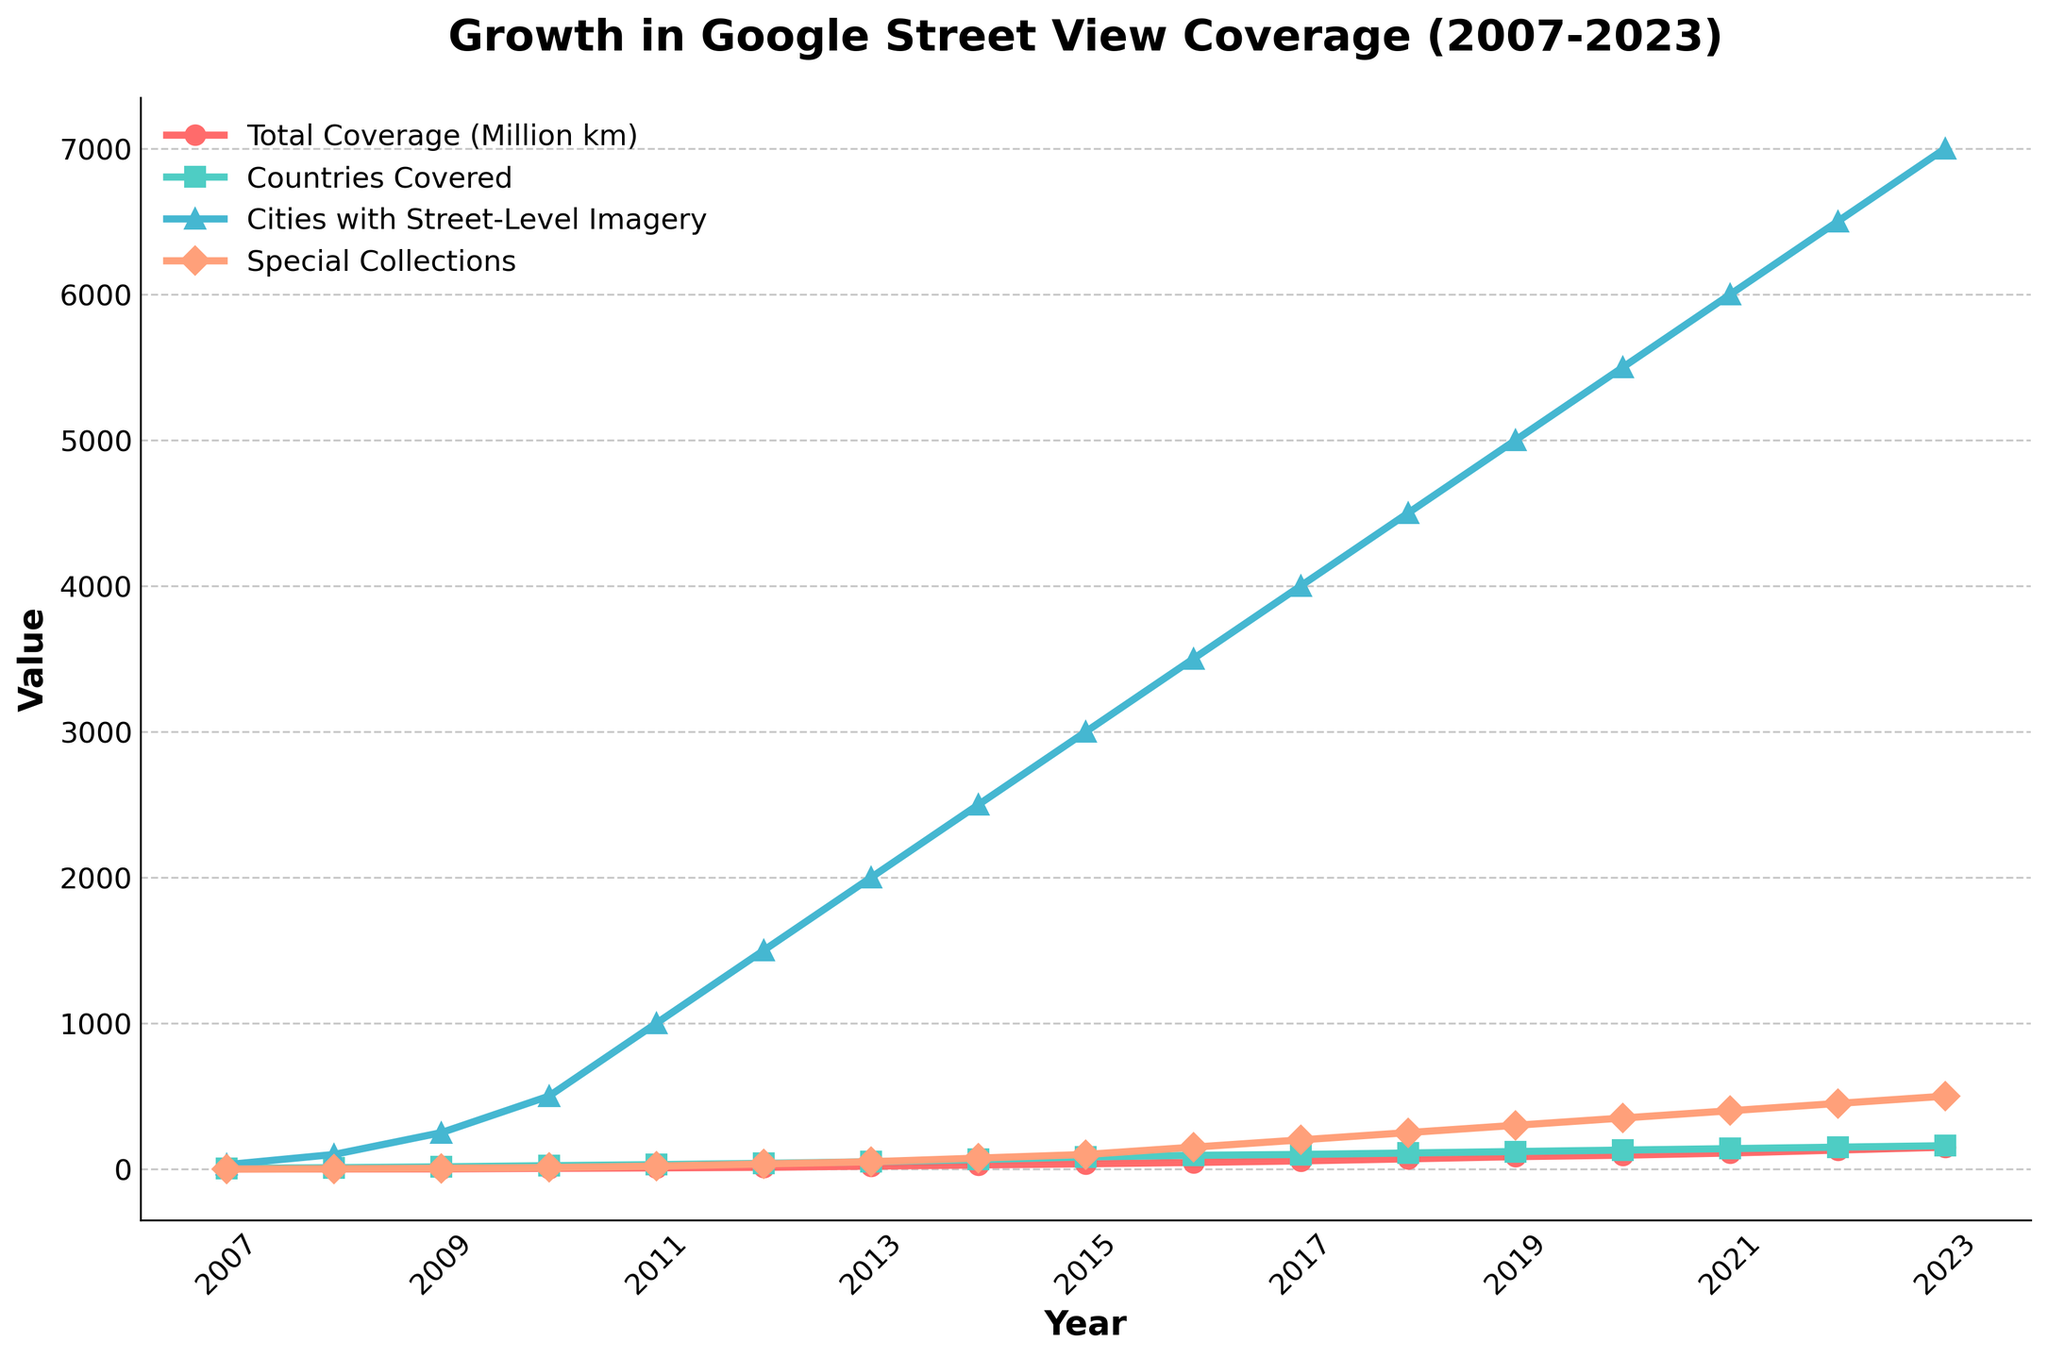What year did Google Street View first reach 10 million km of total coverage? Refer to the "Total Coverage (Million km)" line in the figure. It shows that the total coverage surpassed 10 million km in the year 2010.
Answer: 2010 Between which consecutive years did Google Street View experience the highest increase in the number of cities with street-level imagery? Compare the increases in the "Cities with Street-Level Imagery" line for each consecutive year. The largest increase occurs between 2010 and 2011, where the number rose from 500 to 1000.
Answer: 2010-2011 How many countries did Google Street View cover by 2015? Refer to the "Countries Covered" line in the figure for the year 2015. It shows that 83 countries were covered by Google Street View in that year.
Answer: 83 Which year saw the largest single-year increase in total km coverage, and how much was the increase? Compare yearly increments in the "Total Coverage (Million km)" line. The largest increase occurred between 2017 and 2018, where coverage went from 56 million km to 70 million km, an increase of 14 million km.
Answer: 2017-2018, 14 million km What is the average number of countries covered from 2007 to 2013? Add the number of countries covered from 2007 to 2013 and divide by the number of years. (5 + 9 + 15 + 23 + 30 + 39 + 50) / 7 = 171 / 7 ≈ 24.4
Answer: 24.4 In which year did the number of special collections first reach or surpass 100? Refer to the "Special Collections" line in the figure. It surpassed 100 in the year 2015.
Answer: 2015 Compare the number of cities with street-level imagery in 2010 and 2020. How much did it increase? Subtract the number of cities with street-level imagery in 2010 from 2020. 5500 - 500 = 5000
Answer: 5000 What was the total coverage (in million km) in the year when Google Street View covered 100 countries? Refer to the "Countries Covered" and "Total Coverage (Million km)" lines to identify the year 2017, when 100 countries were covered. The total coverage in that year was 56 million km.
Answer: 56 million km By how many times did the total coverage increase from 2007 to 2023? Divide the total coverage in 2023 by that in 2007. 150 million km / 0.1 million km = 1500
Answer: 1500 What is the trend in the number of special collections over the years? Refer to the slope and shape of the "Special Collections" line. It shows an upward trend, indicating continuous growth over the years.
Answer: Upward trend 